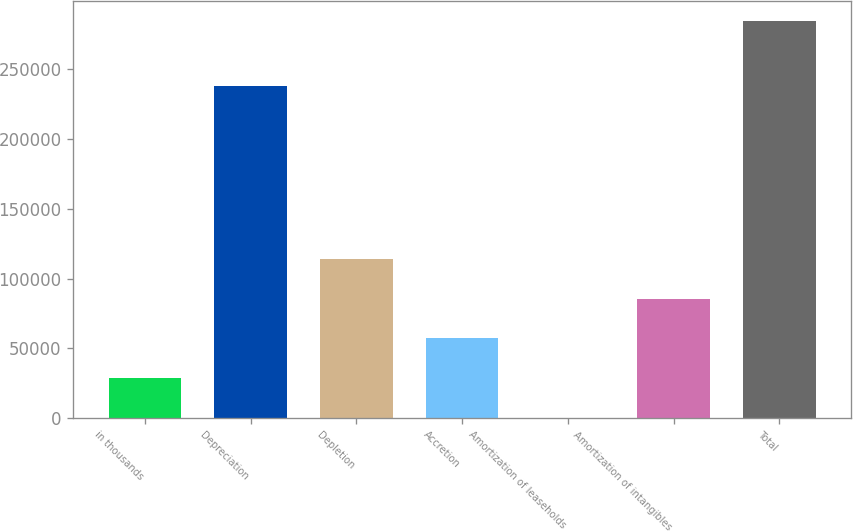Convert chart to OTSL. <chart><loc_0><loc_0><loc_500><loc_500><bar_chart><fcel>in thousands<fcel>Depreciation<fcel>Depletion<fcel>Accretion<fcel>Amortization of leaseholds<fcel>Amortization of intangibles<fcel>Total<nl><fcel>28734.3<fcel>238237<fcel>114136<fcel>57201.6<fcel>267<fcel>85668.9<fcel>284940<nl></chart> 